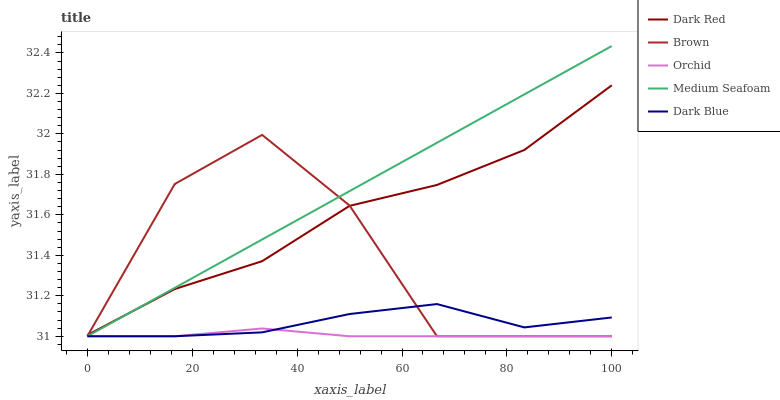Does Dark Blue have the minimum area under the curve?
Answer yes or no. No. Does Dark Blue have the maximum area under the curve?
Answer yes or no. No. Is Dark Blue the smoothest?
Answer yes or no. No. Is Dark Blue the roughest?
Answer yes or no. No. Does Dark Blue have the highest value?
Answer yes or no. No. Is Orchid less than Dark Red?
Answer yes or no. Yes. Is Dark Red greater than Dark Blue?
Answer yes or no. Yes. Does Orchid intersect Dark Red?
Answer yes or no. No. 